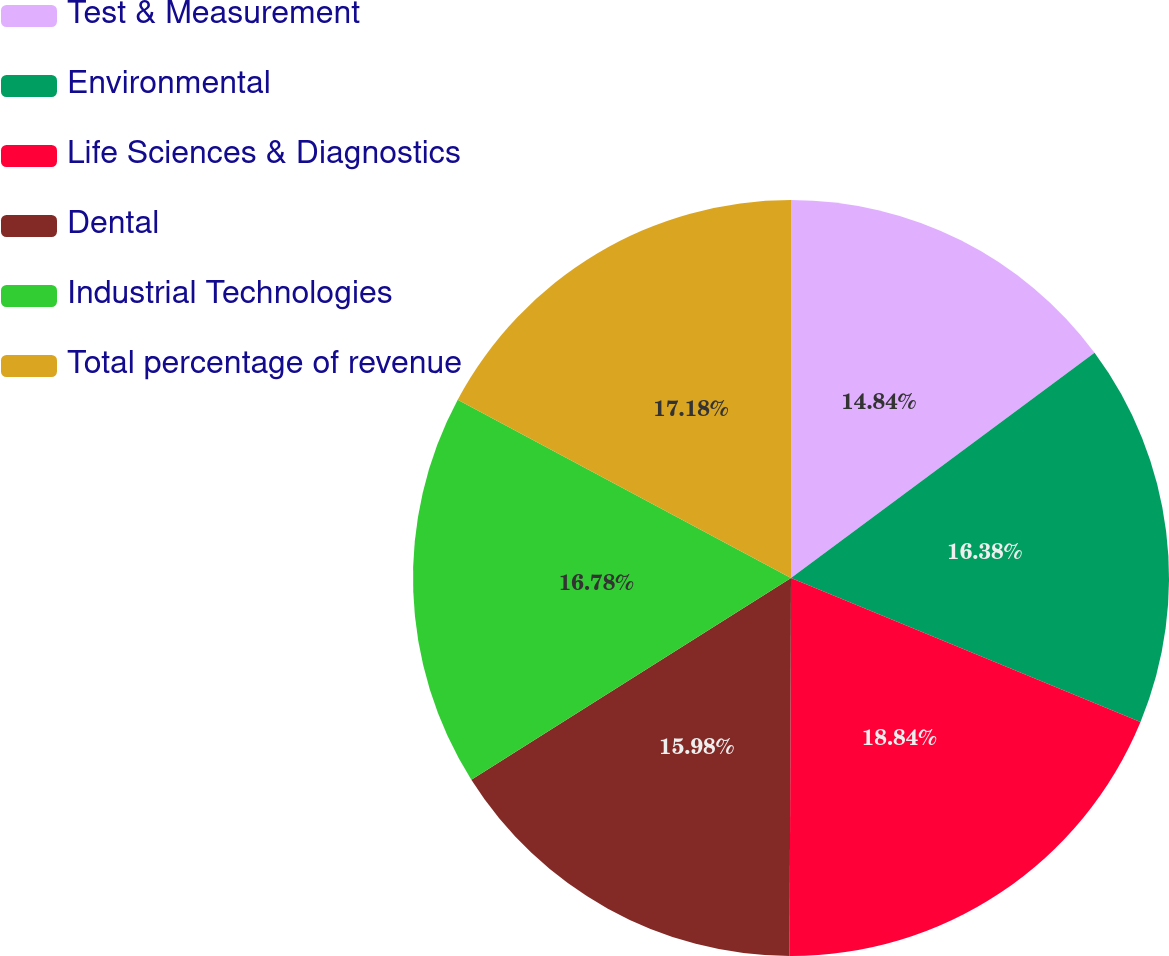<chart> <loc_0><loc_0><loc_500><loc_500><pie_chart><fcel>Test & Measurement<fcel>Environmental<fcel>Life Sciences & Diagnostics<fcel>Dental<fcel>Industrial Technologies<fcel>Total percentage of revenue<nl><fcel>14.84%<fcel>16.38%<fcel>18.84%<fcel>15.98%<fcel>16.78%<fcel>17.18%<nl></chart> 